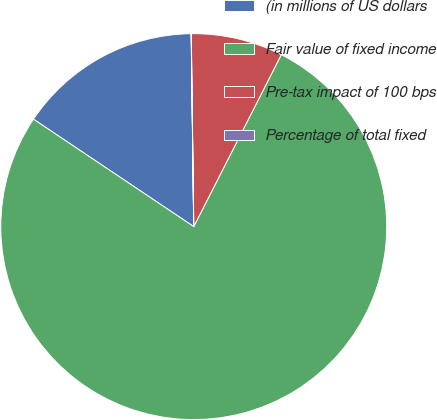Convert chart. <chart><loc_0><loc_0><loc_500><loc_500><pie_chart><fcel>(in millions of US dollars<fcel>Fair value of fixed income<fcel>Pre-tax impact of 100 bps<fcel>Percentage of total fixed<nl><fcel>15.39%<fcel>76.91%<fcel>7.7%<fcel>0.01%<nl></chart> 